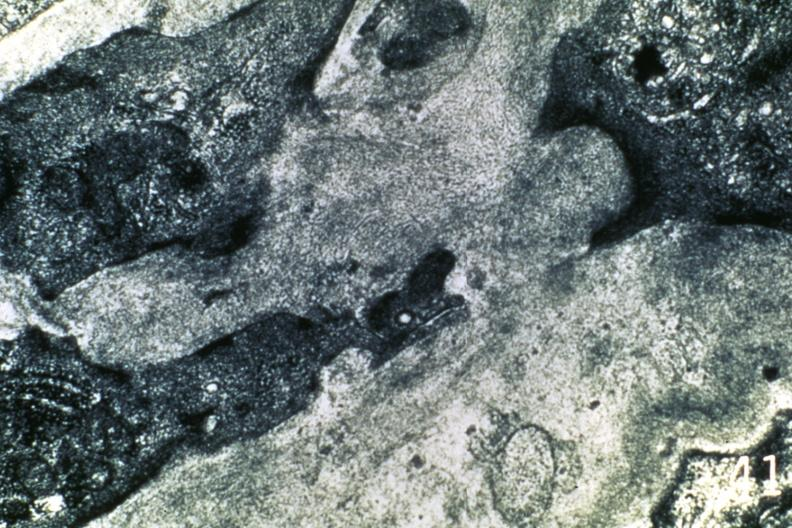what is present?
Answer the question using a single word or phrase. Cardiovascular 